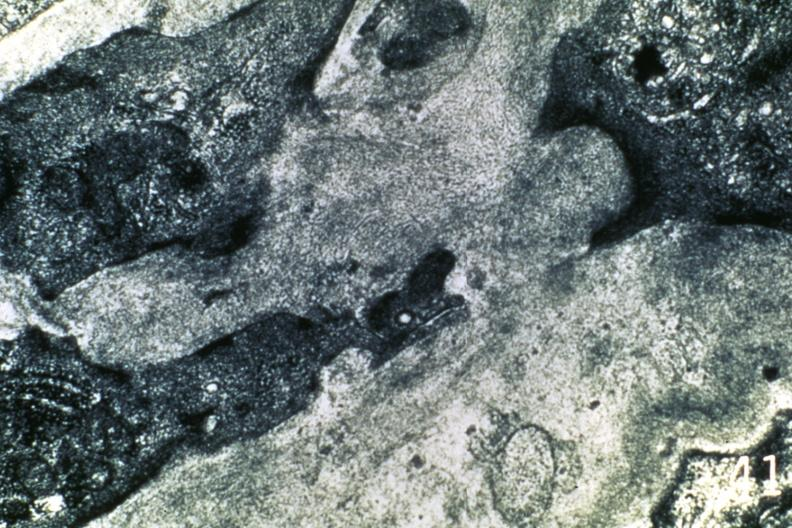what is present?
Answer the question using a single word or phrase. Cardiovascular 